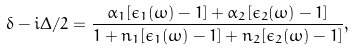Convert formula to latex. <formula><loc_0><loc_0><loc_500><loc_500>\delta - i \Delta / 2 = \frac { \alpha _ { 1 } [ \epsilon _ { 1 } ( \omega ) - 1 ] + \alpha _ { 2 } [ \epsilon _ { 2 } ( \omega ) - 1 ] } { 1 + n _ { 1 } [ \epsilon _ { 1 } ( \omega ) - 1 ] + n _ { 2 } [ \epsilon _ { 2 } ( \omega ) - 1 ] } ,</formula> 